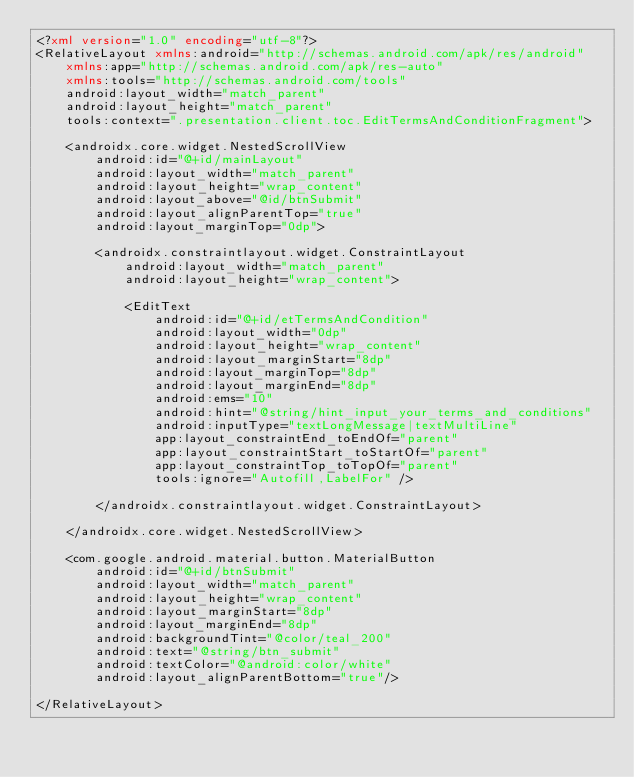<code> <loc_0><loc_0><loc_500><loc_500><_XML_><?xml version="1.0" encoding="utf-8"?>
<RelativeLayout xmlns:android="http://schemas.android.com/apk/res/android"
    xmlns:app="http://schemas.android.com/apk/res-auto"
    xmlns:tools="http://schemas.android.com/tools"
    android:layout_width="match_parent"
    android:layout_height="match_parent"
    tools:context=".presentation.client.toc.EditTermsAndConditionFragment">

    <androidx.core.widget.NestedScrollView
        android:id="@+id/mainLayout"
        android:layout_width="match_parent"
        android:layout_height="wrap_content"
        android:layout_above="@id/btnSubmit"
        android:layout_alignParentTop="true"
        android:layout_marginTop="0dp">

        <androidx.constraintlayout.widget.ConstraintLayout
            android:layout_width="match_parent"
            android:layout_height="wrap_content">

            <EditText
                android:id="@+id/etTermsAndCondition"
                android:layout_width="0dp"
                android:layout_height="wrap_content"
                android:layout_marginStart="8dp"
                android:layout_marginTop="8dp"
                android:layout_marginEnd="8dp"
                android:ems="10"
                android:hint="@string/hint_input_your_terms_and_conditions"
                android:inputType="textLongMessage|textMultiLine"
                app:layout_constraintEnd_toEndOf="parent"
                app:layout_constraintStart_toStartOf="parent"
                app:layout_constraintTop_toTopOf="parent"
                tools:ignore="Autofill,LabelFor" />

        </androidx.constraintlayout.widget.ConstraintLayout>

    </androidx.core.widget.NestedScrollView>

    <com.google.android.material.button.MaterialButton
        android:id="@+id/btnSubmit"
        android:layout_width="match_parent"
        android:layout_height="wrap_content"
        android:layout_marginStart="8dp"
        android:layout_marginEnd="8dp"
        android:backgroundTint="@color/teal_200"
        android:text="@string/btn_submit"
        android:textColor="@android:color/white"
        android:layout_alignParentBottom="true"/>

</RelativeLayout></code> 